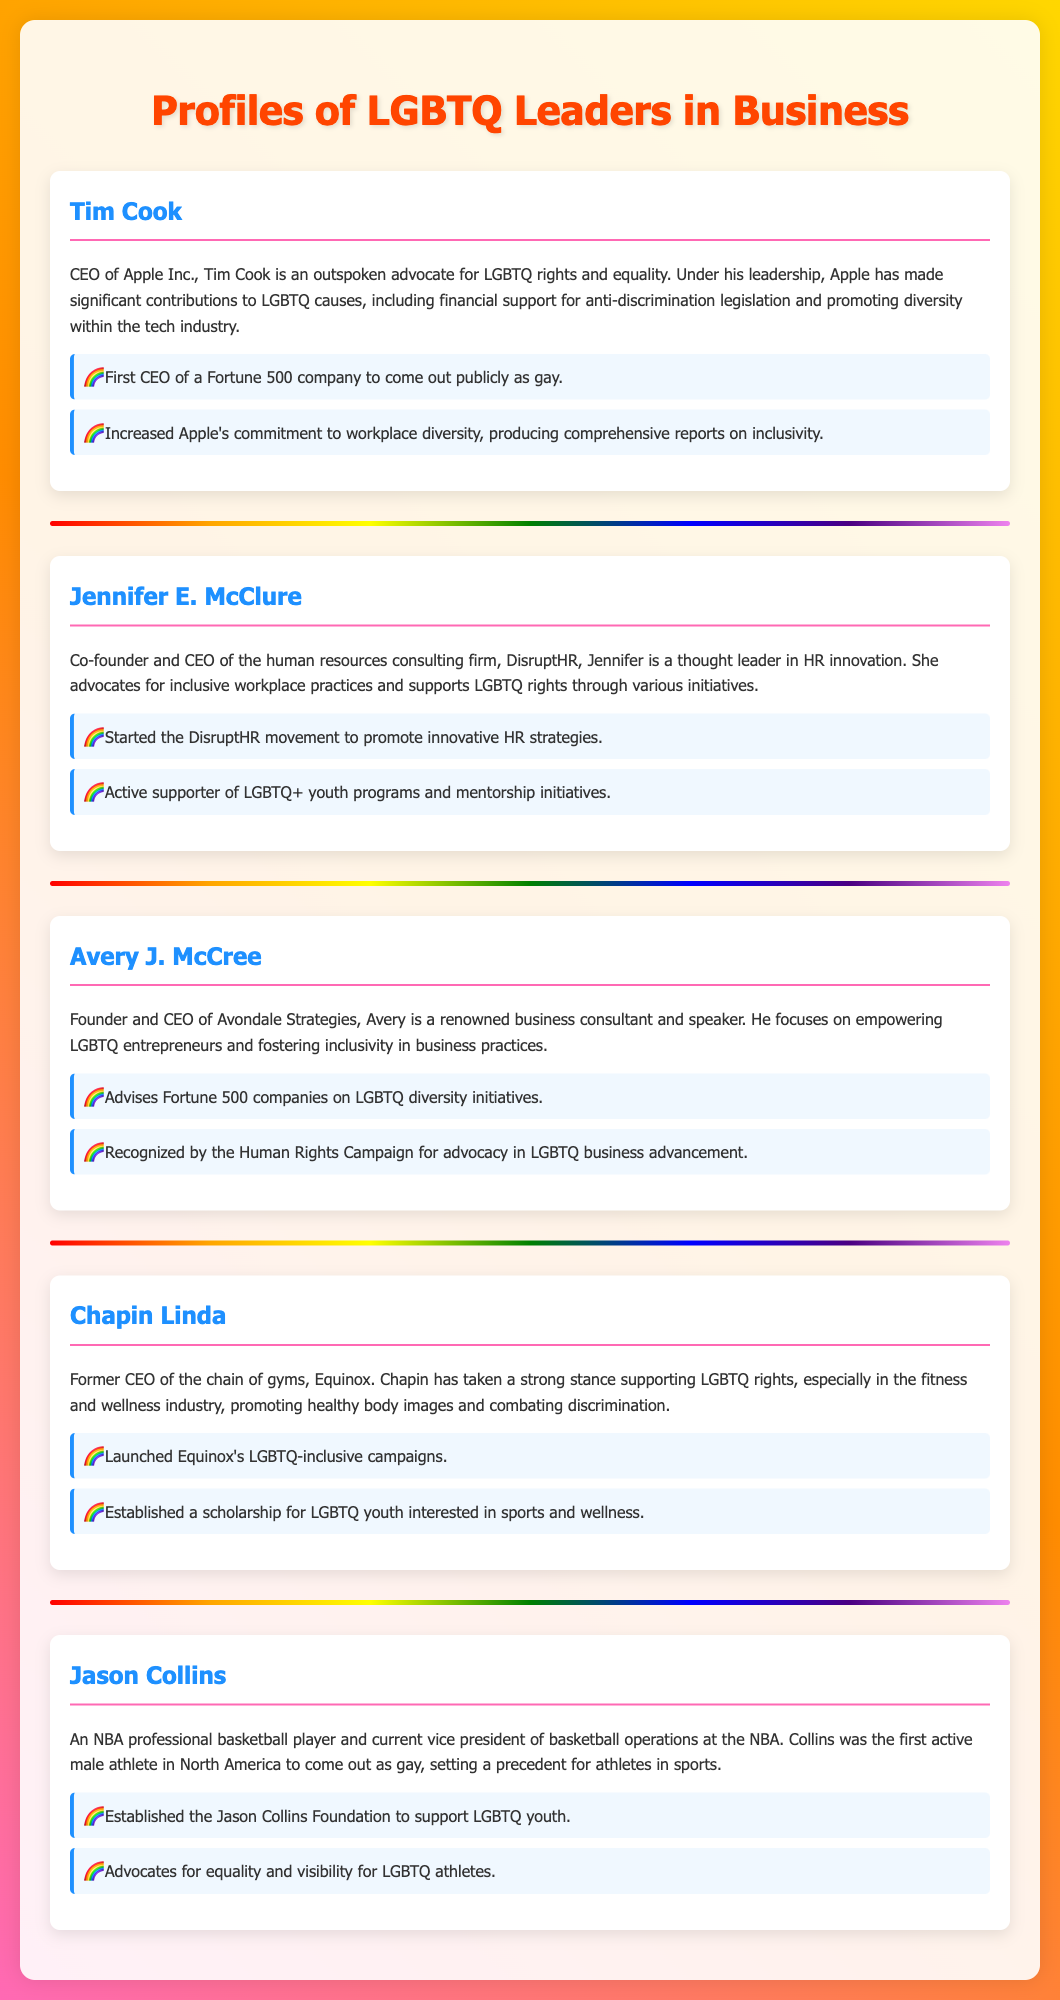What is the title of the document? The title of the document is prominently displayed at the top and introduces the main topic of the content.
Answer: Profiles of LGBTQ Leaders in Business Who is the CEO of Apple Inc.? The document provides a specific individual who holds the position as CEO of Apple Inc., highlighting their contributions and advocacy.
Answer: Tim Cook What initiative did Jennifer E. McClure start? The document mentions a movement started by Jennifer E. McClure aimed at promoting innovative strategies in human resources.
Answer: DisruptHR What type of strategies does Avery J. McCree focus on? The document highlights Avery J. McCree's focus area as a business consultant in relation to a specific group within the business community.
Answer: LGBTQ entrepreneurs What is the achievement associated with Jason Collins? The document lists a notable achievement related to Jason Collins aimed at supporting a particular demographic through his foundation.
Answer: Established the Jason Collins Foundation Which industry did Chapin Linda impact through their leadership? The document identifies a specific industry where Chapin Linda made significant contributions and took a strong stance for a community.
Answer: Fitness and wellness What color is used for the headings of the leader cards? The document describes the color used in the headings of the leader cards, which contributes to the visual appeal.
Answer: #1e90ff How many leaders are profiled in the document? The document lists a total number of individuals who are highlighted as leaders, showcasing their contributions and achievements.
Answer: Five 